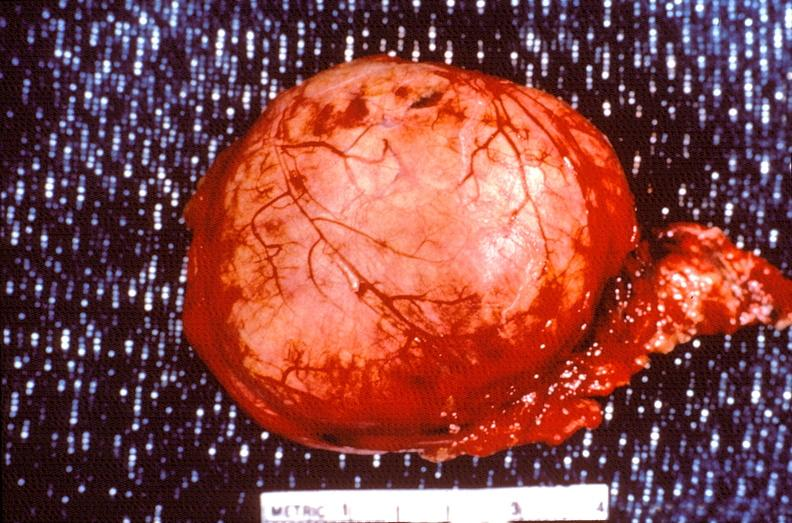what is present?
Answer the question using a single word or phrase. Endocrine 